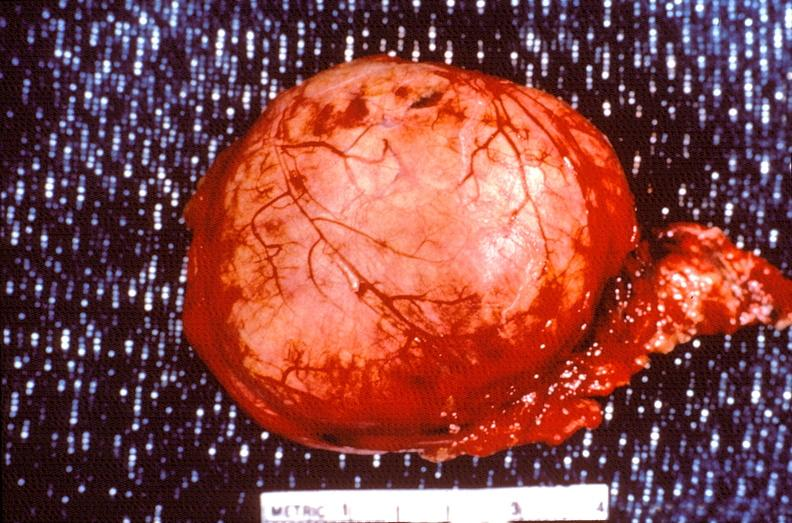what is present?
Answer the question using a single word or phrase. Endocrine 